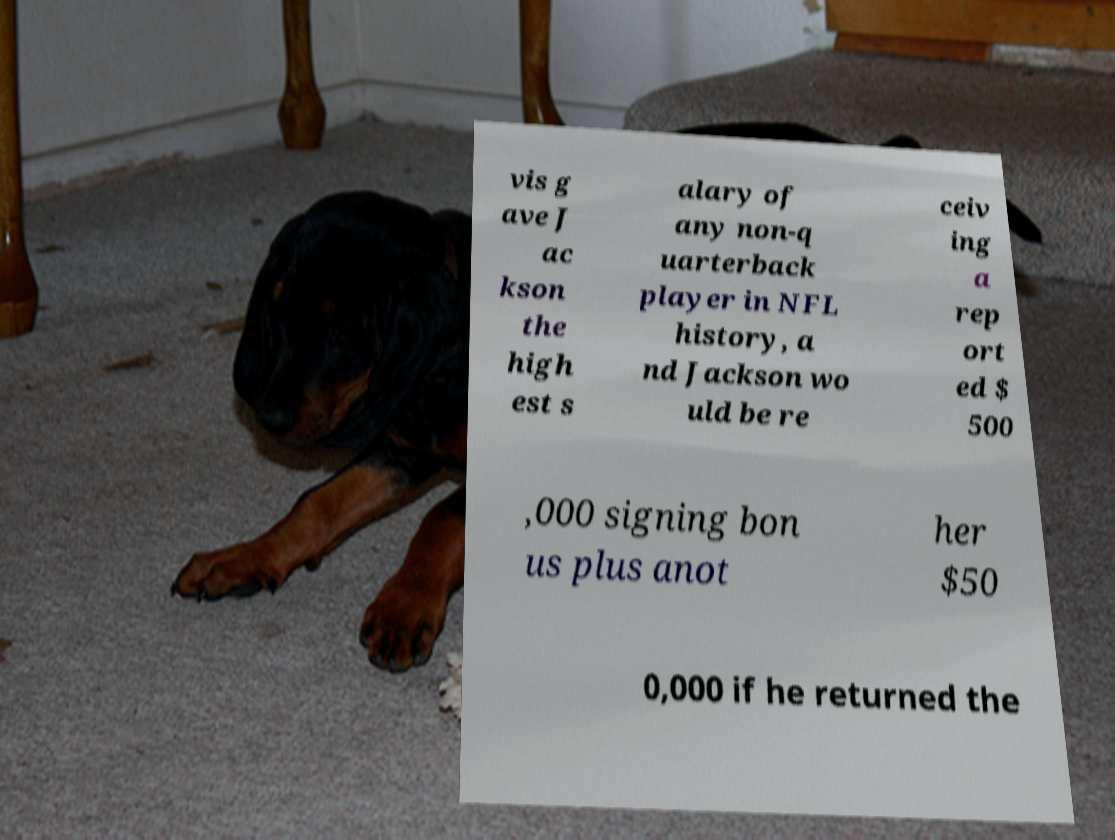There's text embedded in this image that I need extracted. Can you transcribe it verbatim? vis g ave J ac kson the high est s alary of any non-q uarterback player in NFL history, a nd Jackson wo uld be re ceiv ing a rep ort ed $ 500 ,000 signing bon us plus anot her $50 0,000 if he returned the 